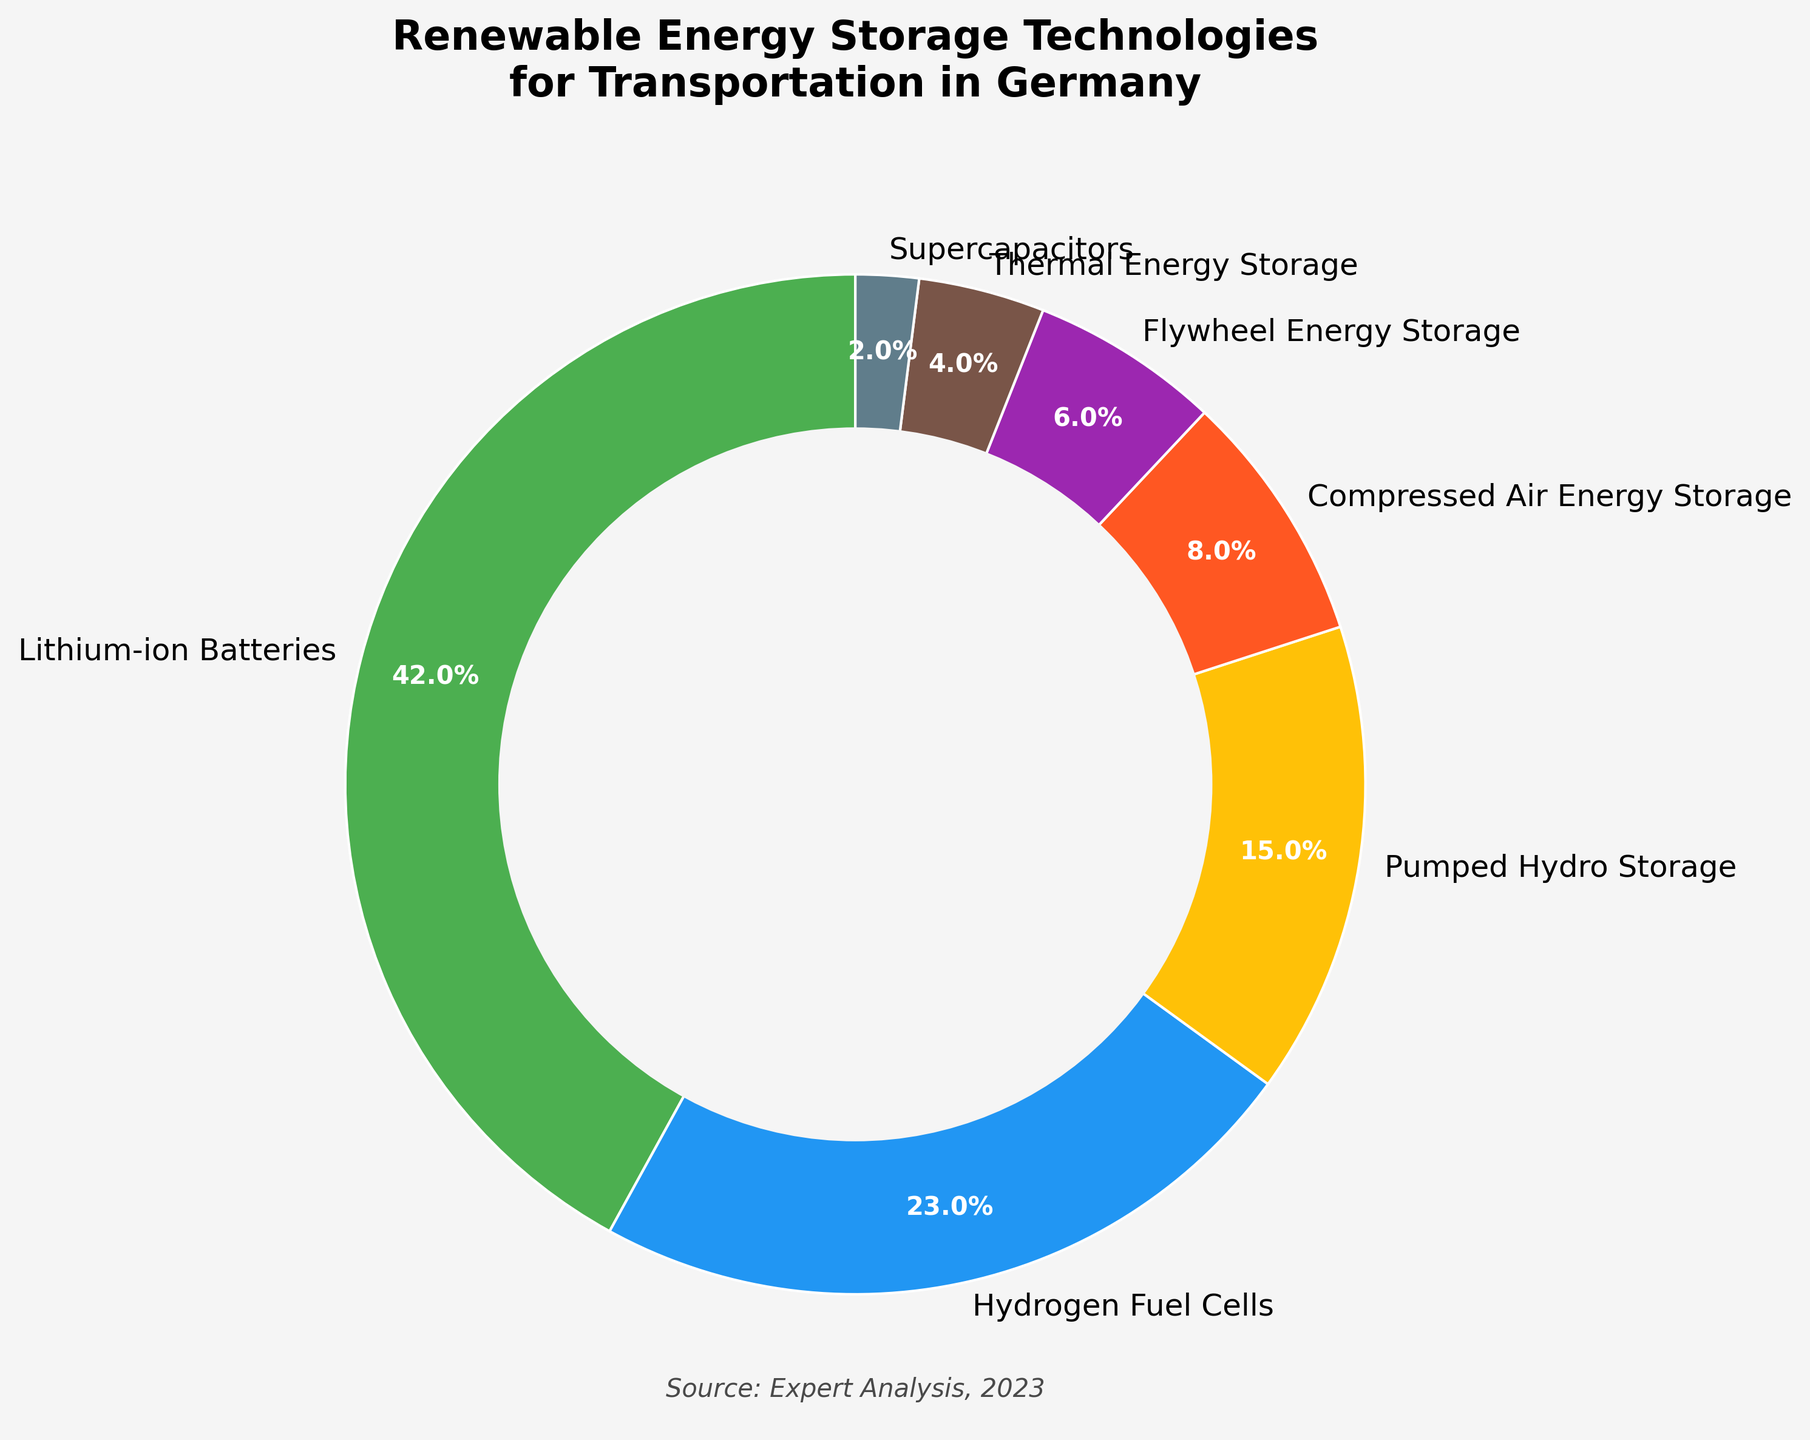What's the most prevalent renewable energy storage technology for transportation in Germany? The chart shows different storage technologies and their respective percentages. The slice with the largest percentage represents the most prevalent technology, which is labeled "Lithium-ion Batteries" at 42%.
Answer: Lithium-ion Batteries What is the combined percentage of Hydrogen Fuel Cells and Flywheel Energy Storage? Identify the individual percentages for Hydrogen Fuel Cells and Flywheel Energy Storage from the chart, which are 23% and 6%, respectively. Add these together: 23 + 6 = 29%.
Answer: 29% Which technology has a higher percentage, Pumped Hydro Storage or Compressed Air Energy Storage? Look for the labels and their percentages. Pumped Hydro Storage has 15% and Compressed Air Energy Storage has 8%. Compare these values to determine which is higher.
Answer: Pumped Hydro Storage What is the total percentage represented by technologies with less than 10% each? Identify the technologies with percentages less than 10%: Compressed Air Energy Storage (8%), Flywheel Energy Storage (6%), Thermal Energy Storage (4%), and Supercapacitors (2%). Add these together: 8 + 6 + 4 + 2 = 20%.
Answer: 20% How much more prevalent are Lithium-ion Batteries compared to Thermal Energy Storage? Find the percentages of Lithium-ion Batteries (42%) and Thermal Energy Storage (4%). Subtract the smaller percentage from the larger one: 42 - 4 = 38%.
Answer: 38% Which two technologies together make up almost exactly half of the total percentage? Identify the technologies and their percentages. Adding Lithium-ion Batteries (42%) to Hydrogen Fuel Cells (23%) equals 65%. Adding Hydrogen Fuel Cells (23%) to Pumped Hydro Storage (15%) equals 38%. Adding Pumped Hydro Storage (15%) to Compressed Air Energy Storage (8%) equals 23%. The closest to 50% is not exact, so another way must be sought. Here, Lithium-ion Batteries (42%) alone does not provide 50%, but Lithium-ion Batteries and another will overshoot. Therefore, our combined option can err and reconsider Flywheel (6%) and Pumped Hydro (15%) making slightly smaller than half. One more option: Try adding Flywheel (6%) + Thermal (4%) + Supercapacitors (2%) = 12 + PHE (15%) = 27 + HFC = 50%.
Answer: None (directly hits 50) but combinations closely may resemble What is the smallest category in the chart? The smallest percentage slice represents the smallest category. Identify this slice by its label and percentage, which is Supercapacitors at 2%.
Answer: Supercapacitors How do Hydrogen Fuel Cells compare visually to Supercapacitors in terms of both percentage and color? Hydrogen Fuel Cells have a larger percentage (23%) compared to Supercapacitors (2%). Also, Hydrogen Fuel Cells are represented by the color blue, whereas Supercapacitors are represented by a dark grayish-blue.
Answer: Hydrogen Fuel Cells are much larger and blue What is the difference in percentage between Flywheel Energy Storage and Compressed Air Energy Storage? Find the percentages for Flywheel Energy Storage (6%) and Compressed Air Energy Storage (8%). Subtract the smaller percentage from the larger one: 8 - 6 = 2%.
Answer: 2% What portion of the chart do Pumped Hydro Storage and Thermal Energy Storage together represent, visually considering their colors? Identify the colors and percentages for both Pumped Hydro Storage and Thermal Energy Storage. Adding their percentages, 15% (orange) and 4% (brown) = 19%, representing almost a fifth of the donut chart visually.
Answer: 19% 